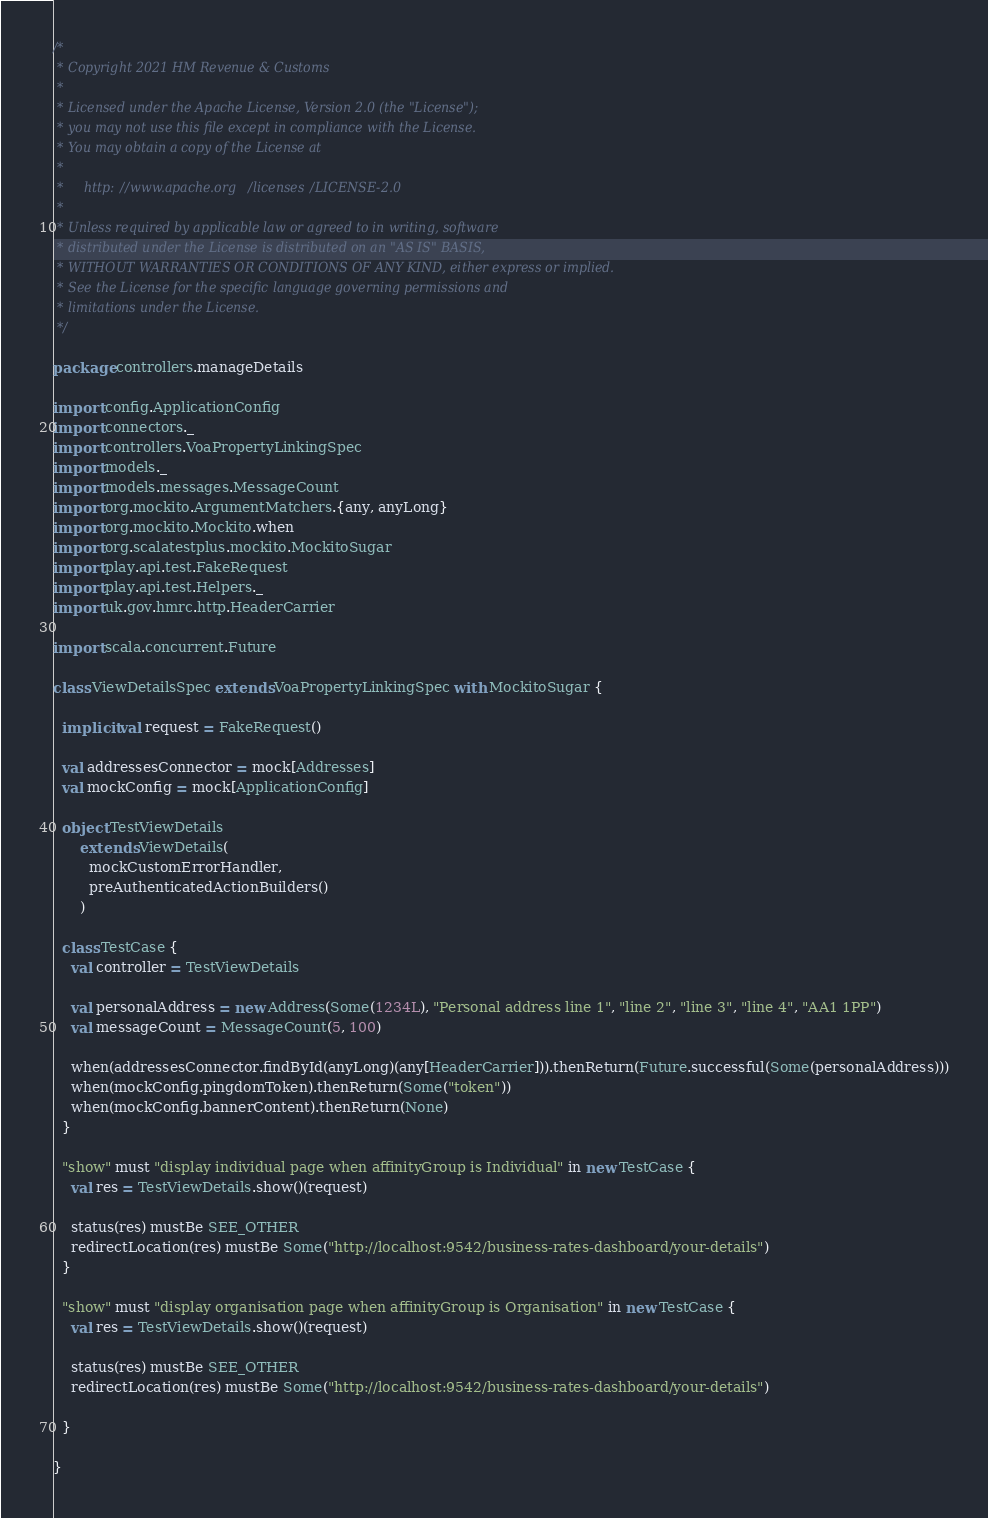<code> <loc_0><loc_0><loc_500><loc_500><_Scala_>/*
 * Copyright 2021 HM Revenue & Customs
 *
 * Licensed under the Apache License, Version 2.0 (the "License");
 * you may not use this file except in compliance with the License.
 * You may obtain a copy of the License at
 *
 *     http://www.apache.org/licenses/LICENSE-2.0
 *
 * Unless required by applicable law or agreed to in writing, software
 * distributed under the License is distributed on an "AS IS" BASIS,
 * WITHOUT WARRANTIES OR CONDITIONS OF ANY KIND, either express or implied.
 * See the License for the specific language governing permissions and
 * limitations under the License.
 */

package controllers.manageDetails

import config.ApplicationConfig
import connectors._
import controllers.VoaPropertyLinkingSpec
import models._
import models.messages.MessageCount
import org.mockito.ArgumentMatchers.{any, anyLong}
import org.mockito.Mockito.when
import org.scalatestplus.mockito.MockitoSugar
import play.api.test.FakeRequest
import play.api.test.Helpers._
import uk.gov.hmrc.http.HeaderCarrier

import scala.concurrent.Future

class ViewDetailsSpec extends VoaPropertyLinkingSpec with MockitoSugar {

  implicit val request = FakeRequest()

  val addressesConnector = mock[Addresses]
  val mockConfig = mock[ApplicationConfig]

  object TestViewDetails
      extends ViewDetails(
        mockCustomErrorHandler,
        preAuthenticatedActionBuilders()
      )

  class TestCase {
    val controller = TestViewDetails

    val personalAddress = new Address(Some(1234L), "Personal address line 1", "line 2", "line 3", "line 4", "AA1 1PP")
    val messageCount = MessageCount(5, 100)

    when(addressesConnector.findById(anyLong)(any[HeaderCarrier])).thenReturn(Future.successful(Some(personalAddress)))
    when(mockConfig.pingdomToken).thenReturn(Some("token"))
    when(mockConfig.bannerContent).thenReturn(None)
  }

  "show" must "display individual page when affinityGroup is Individual" in new TestCase {
    val res = TestViewDetails.show()(request)

    status(res) mustBe SEE_OTHER
    redirectLocation(res) mustBe Some("http://localhost:9542/business-rates-dashboard/your-details")
  }

  "show" must "display organisation page when affinityGroup is Organisation" in new TestCase {
    val res = TestViewDetails.show()(request)

    status(res) mustBe SEE_OTHER
    redirectLocation(res) mustBe Some("http://localhost:9542/business-rates-dashboard/your-details")

  }

}
</code> 